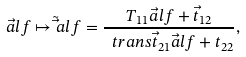Convert formula to latex. <formula><loc_0><loc_0><loc_500><loc_500>\vec { a } l f \mapsto \tilde { \vec } a l f = \frac { T _ { 1 1 } \vec { a } l f + \vec { t } _ { 1 2 } } { \ t r a n s \vec { t } _ { 2 1 } \vec { a } l f + t _ { 2 2 } } ,</formula> 